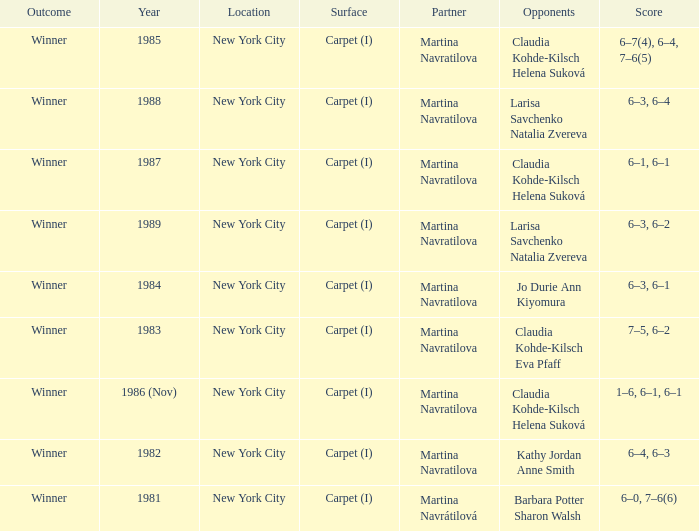What was the outcome for the match in 1989? Winner. 